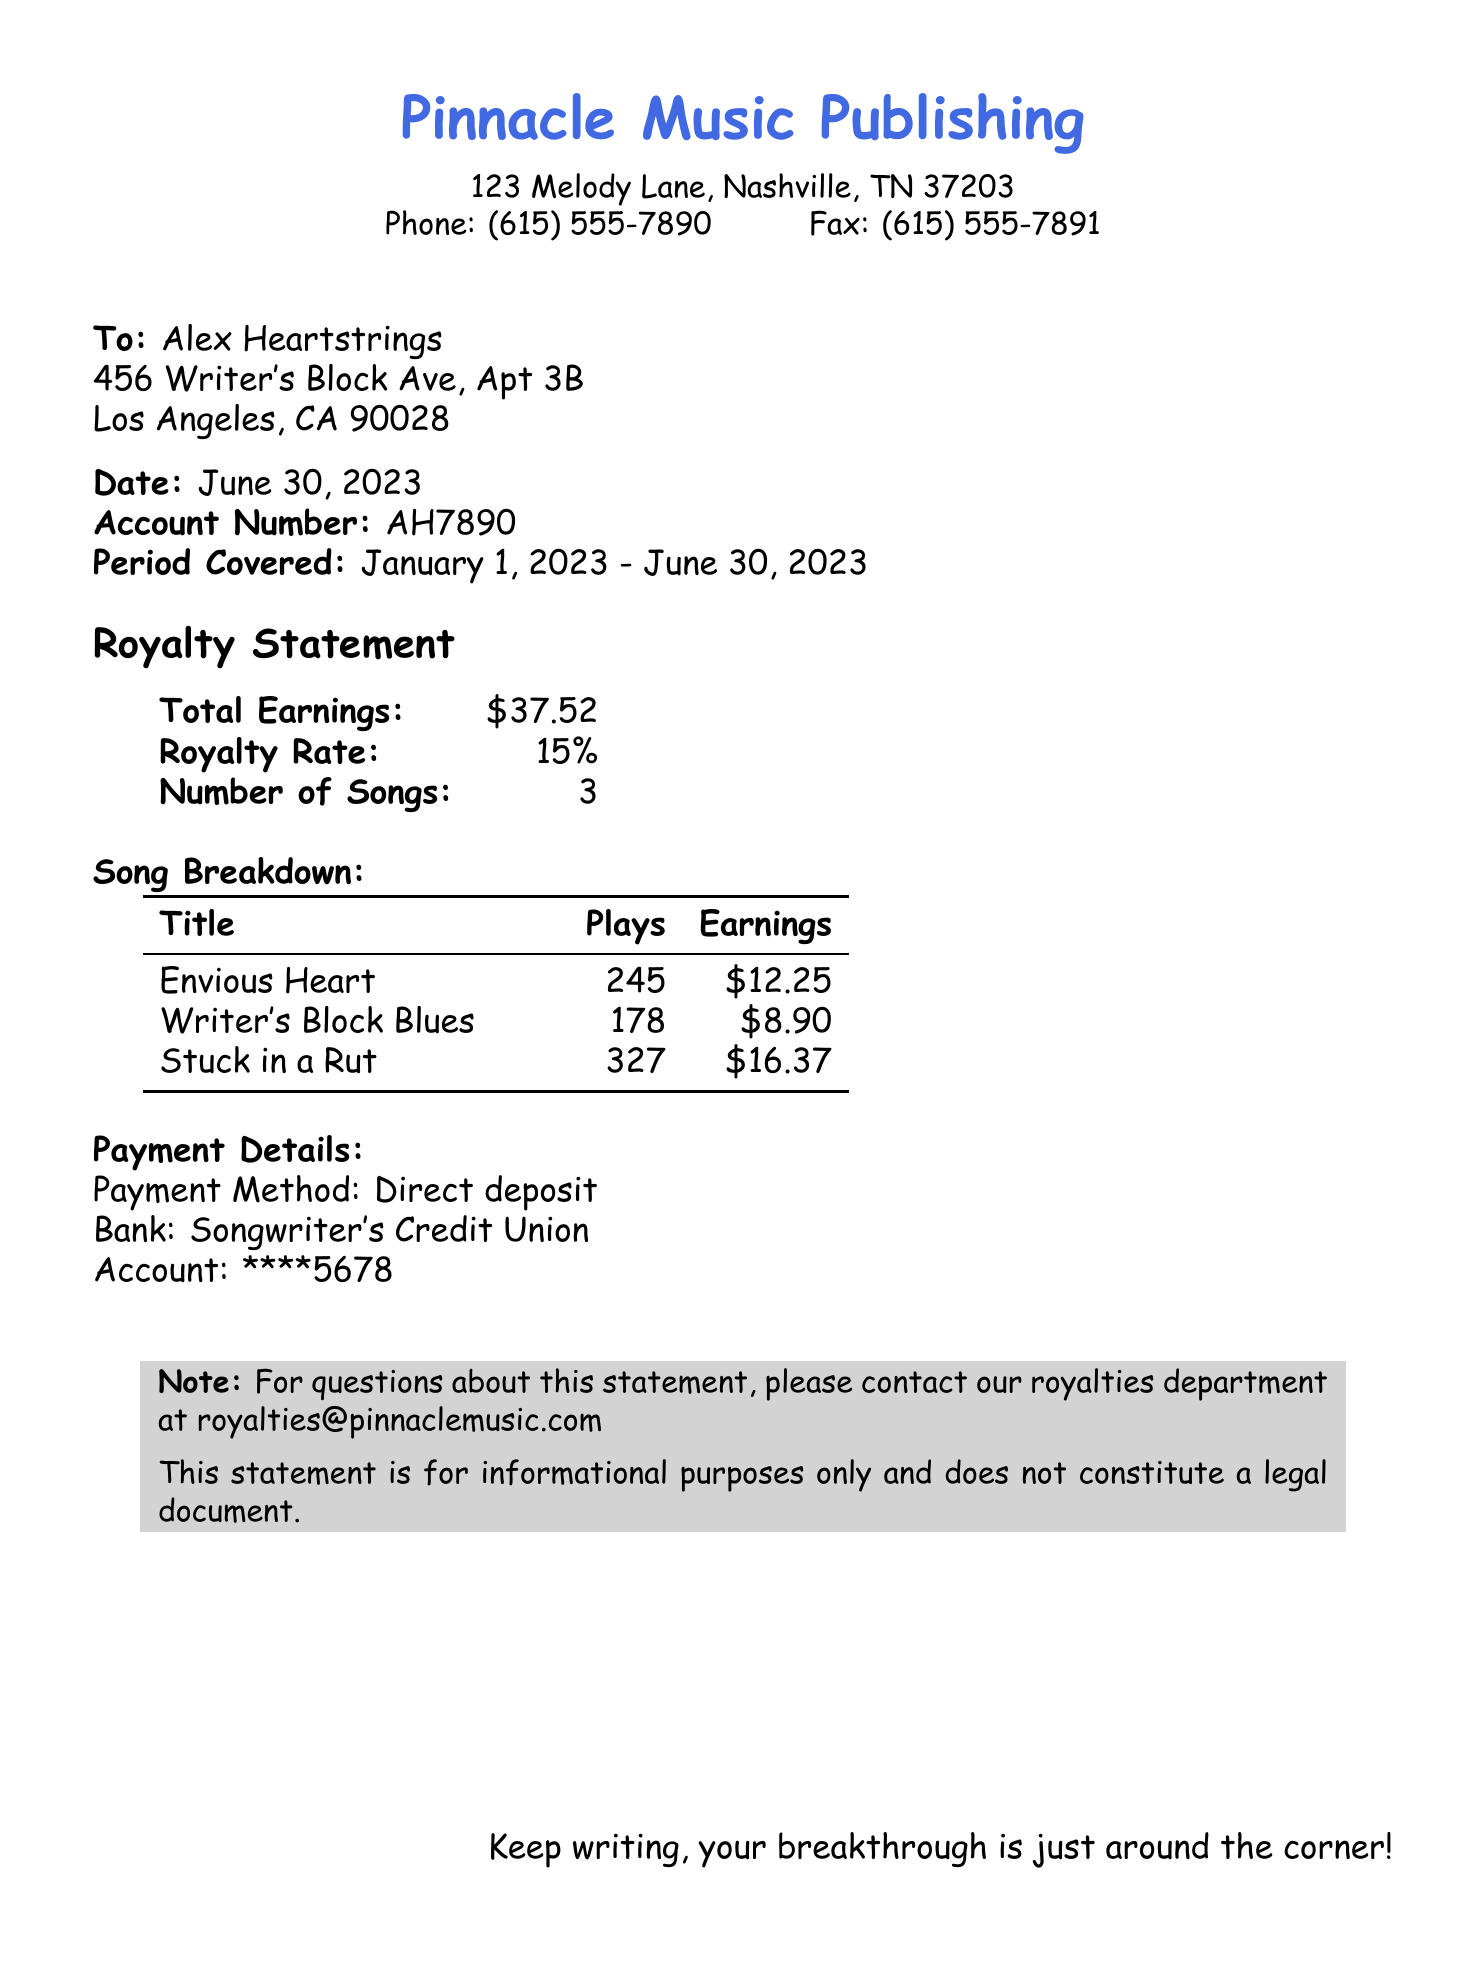what is the account number? The account number is clearly stated in the document as AH7890.
Answer: AH7890 what is the total earnings reported? The total earnings are summarized in the document as $37.52.
Answer: $37.52 who is the recipient of this royalty statement? The recipient's name and address are listed as Alex Heartstrings, and the address is provided in the document.
Answer: Alex Heartstrings what is the royalty rate indicated? The royalty rate is presented in the document as 15%.
Answer: 15% how many songs are listed in the breakdown? The song breakdown section mentions the number of songs as 3.
Answer: 3 which song earned the highest amount? The song breakdown indicates "Stuck in a Rut" earned the most, totaling $16.37.
Answer: Stuck in a Rut what period does this royalty statement cover? The period covered by the royalty statement is from January 1, 2023 to June 30, 2023.
Answer: January 1, 2023 - June 30, 2023 what payment method is used for this statement? The payment method specified in the document is direct deposit.
Answer: Direct deposit what is the total number of plays for all songs combined? The total number of plays is calculated as the sum of all plays from the song breakdown, which can be found in the document.
Answer: 750 